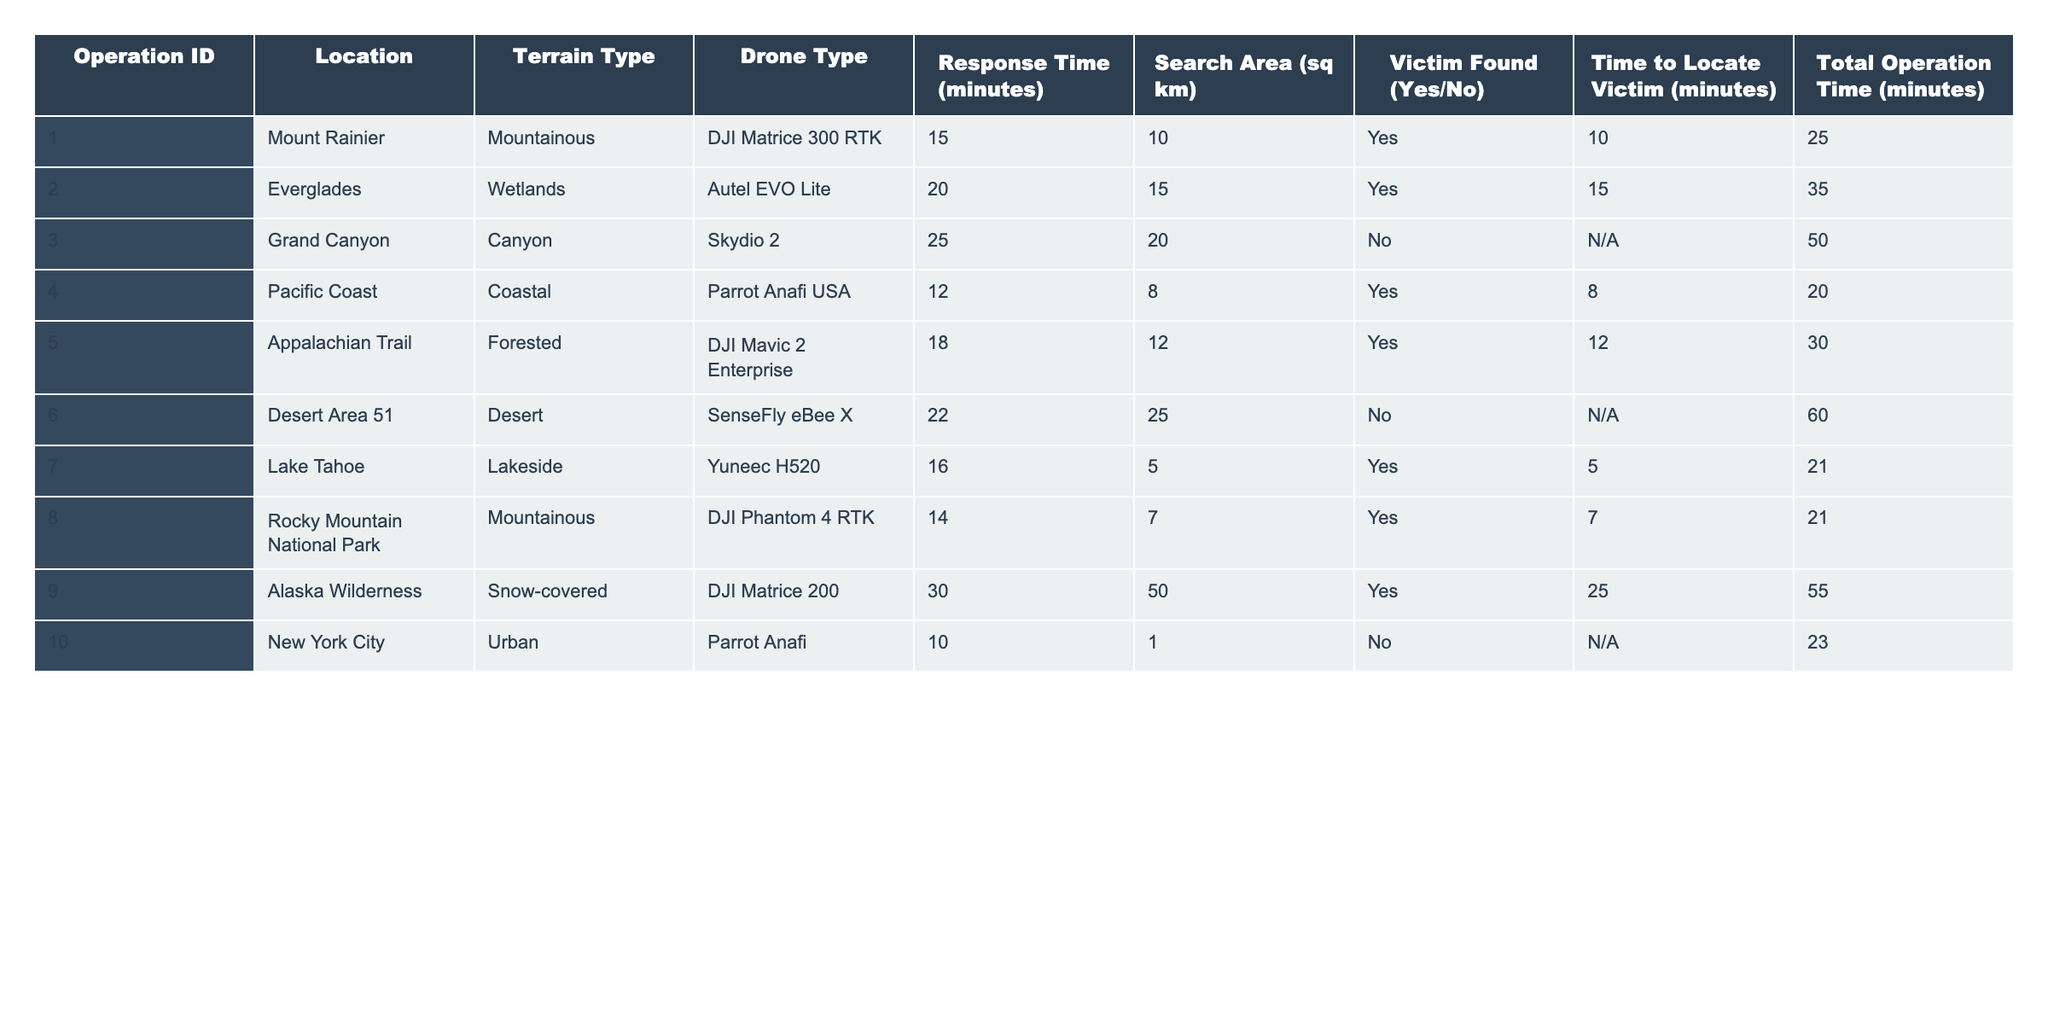What is the shortest response time recorded in the table? The response times listed in the table are: 15, 20, 25, 12, 18, 22, 16, 14, 30, and 10 minutes. The minimum value among these is 10 minutes, which corresponds to Operation ID 010 in New York City.
Answer: 10 minutes Which terrain type has the longest average response time? To find the average response time for each terrain type: Mountainous (15 + 25 + 14) / 3 = 18 minutes, Wetlands (20) = 20 minutes, Canyon (25) = 25 minutes, Coastal (12) = 12 minutes, Forested (18) = 18 minutes, Desert (22) = 22 minutes, Lakeside (16) = 16 minutes, Urban (10) = 10 minutes. The longest average is 25 minutes for Canyon type.
Answer: Canyon Did the drone used in Operation ID 008 successfully locate a victim? Checking the information under "Victim Found" for Operation ID 008, it states "Yes," indicating that a victim was successfully located.
Answer: Yes How many operations had a total operation time over 30 minutes? The total operation times listed are: 25, 35, 50, 20, 30, 60, 21, 21, 55, and 23 minutes. Counting the instances over 30 minutes (35, 50, 60, and 55), there are 4 operations that exceeded this time.
Answer: 4 operations What is the average time taken to locate a victim across all successful operations? First, identify the successful operations: IDs 001, 002, 004, 005, 007, 008, and 009, with their respective times: 10, 15, 8, 12, 5, 7, and 25 minutes. The total time is 10 + 15 + 8 + 12 + 5 + 7 + 25 = 82 minutes for 7 operations, leading to an average of 82/7 = approximately 11.71 minutes.
Answer: Approximately 11.71 minutes Which drone type corresponds with the highest total operation time? Reviewing the total operation times, DJI Matrice 200 has 55 minutes, which is the highest. We compare it with the total times of other drone types: 25, 35, 20, 30, 60, 21, 21, and 23 minutes, confirming that 55 is the maximum.
Answer: DJI Matrice 200 Is there any operation in which the victim was not found but the search area was over 20 square kilometers? The operations where a victim was not found are IDs 003 and 006. Out of these, only ID 006 has a search area of 25 square kilometers, meeting the criteria.
Answer: Yes What is the average area of all the operations where a victim was found? The areas for successful operations (IDs 001, 002, 004, 005, 007, 008, 009) are: 10, 15, 8, 12, 5, 7, and 50 square kilometers. Summing these gives 10 + 15 + 8 + 12 + 5 + 7 + 50 = 107 sq km over 7 operations, leading to an average of 107/7 = 15.29 sq km.
Answer: Approximately 15.29 sq km Which location had the quickest response time and what was the drone type used? Looking at the response times, the quickest is 10 minutes at New York City (Operation ID 010), using the Parrot Anafi drone.
Answer: New York City with Parrot Anafi If we exclude operations that did not find victims, what is the response time of the operation with the highest value? The operations that found victims have response times of 15, 20, 12, 18, 16, 14, and 30 minutes. The highest value among these is 30 minutes from Operation ID 009, Alaska Wilderness.
Answer: 30 minutes How many different types of drones were used across all operations? The drone types listed are: DJI Matrice 300 RTK, Autel EVO Lite, Skydio 2, Parrot Anafi USA, DJI Mavic 2 Enterprise, SenseFly eBee X, Yuneec H520, DJI Phantom 4 RTK, DJI Matrice 200, and Parrot Anafi. There are 10 unique types of drones used.
Answer: 10 